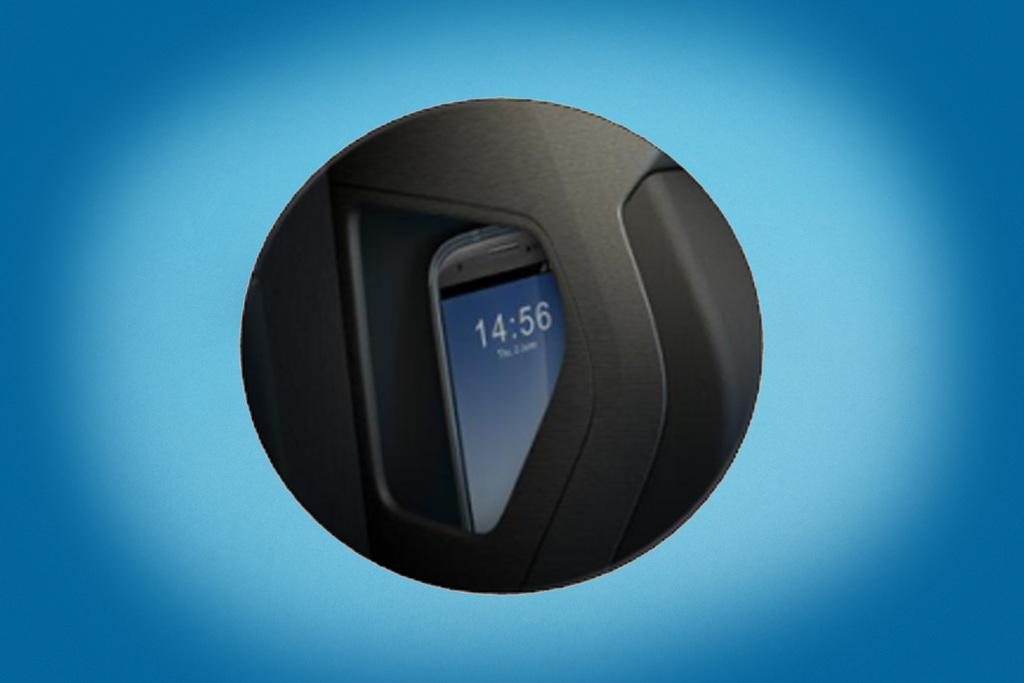Provide a one-sentence caption for the provided image. Part of a phone that reads 14:56 on the screen. 